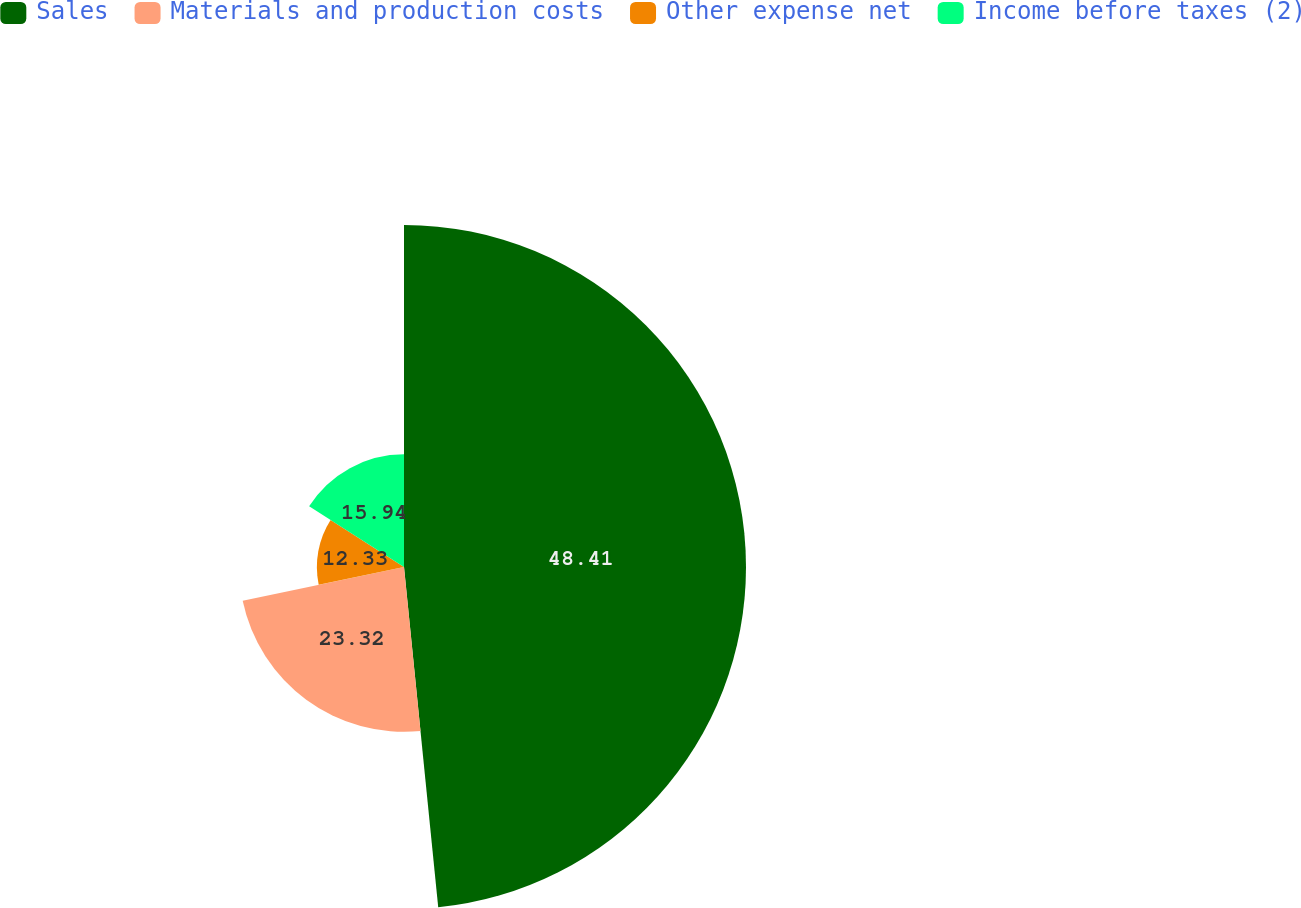<chart> <loc_0><loc_0><loc_500><loc_500><pie_chart><fcel>Sales<fcel>Materials and production costs<fcel>Other expense net<fcel>Income before taxes (2)<nl><fcel>48.4%<fcel>23.32%<fcel>12.33%<fcel>15.94%<nl></chart> 